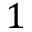Convert formula to latex. <formula><loc_0><loc_0><loc_500><loc_500>1</formula> 